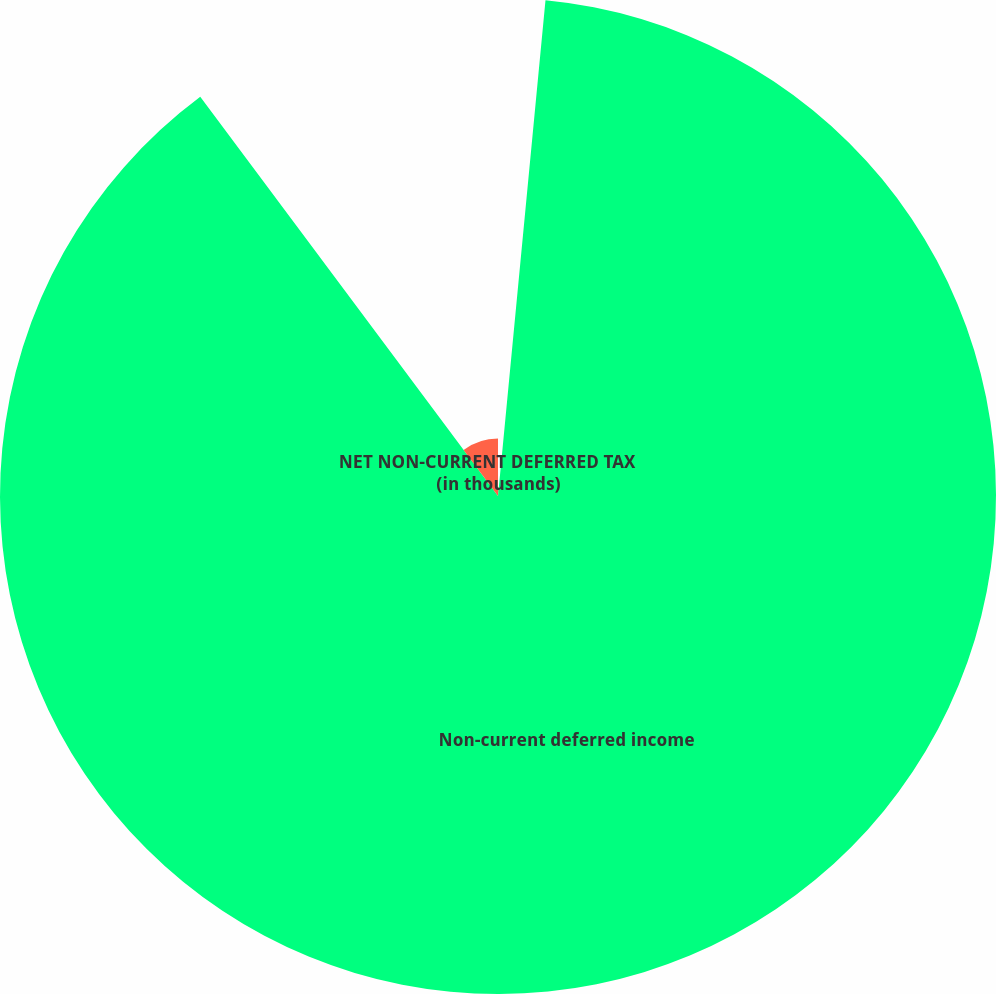Convert chart. <chart><loc_0><loc_0><loc_500><loc_500><pie_chart><fcel>(in thousands)<fcel>Non-current deferred income<fcel>NET NON-CURRENT DEFERRED TAX<nl><fcel>1.52%<fcel>88.28%<fcel>10.2%<nl></chart> 